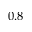Convert formula to latex. <formula><loc_0><loc_0><loc_500><loc_500>0 . 8</formula> 